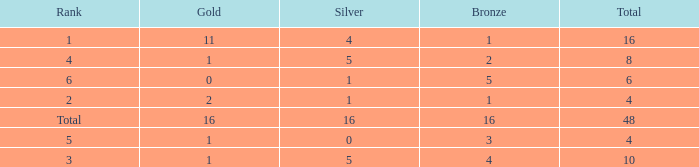How many total gold are less than 4? 0.0. 